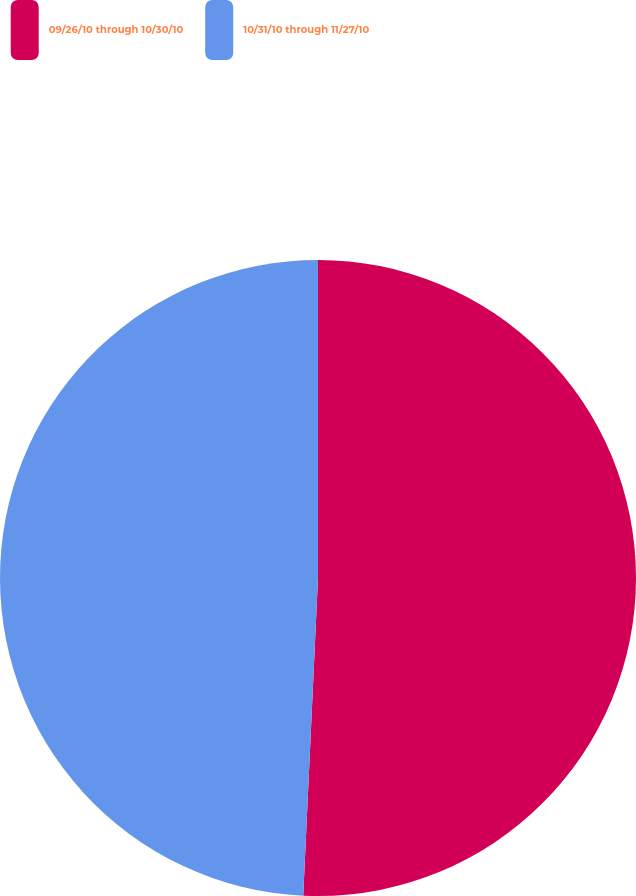<chart> <loc_0><loc_0><loc_500><loc_500><pie_chart><fcel>09/26/10 through 10/30/10<fcel>10/31/10 through 11/27/10<nl><fcel>50.74%<fcel>49.26%<nl></chart> 